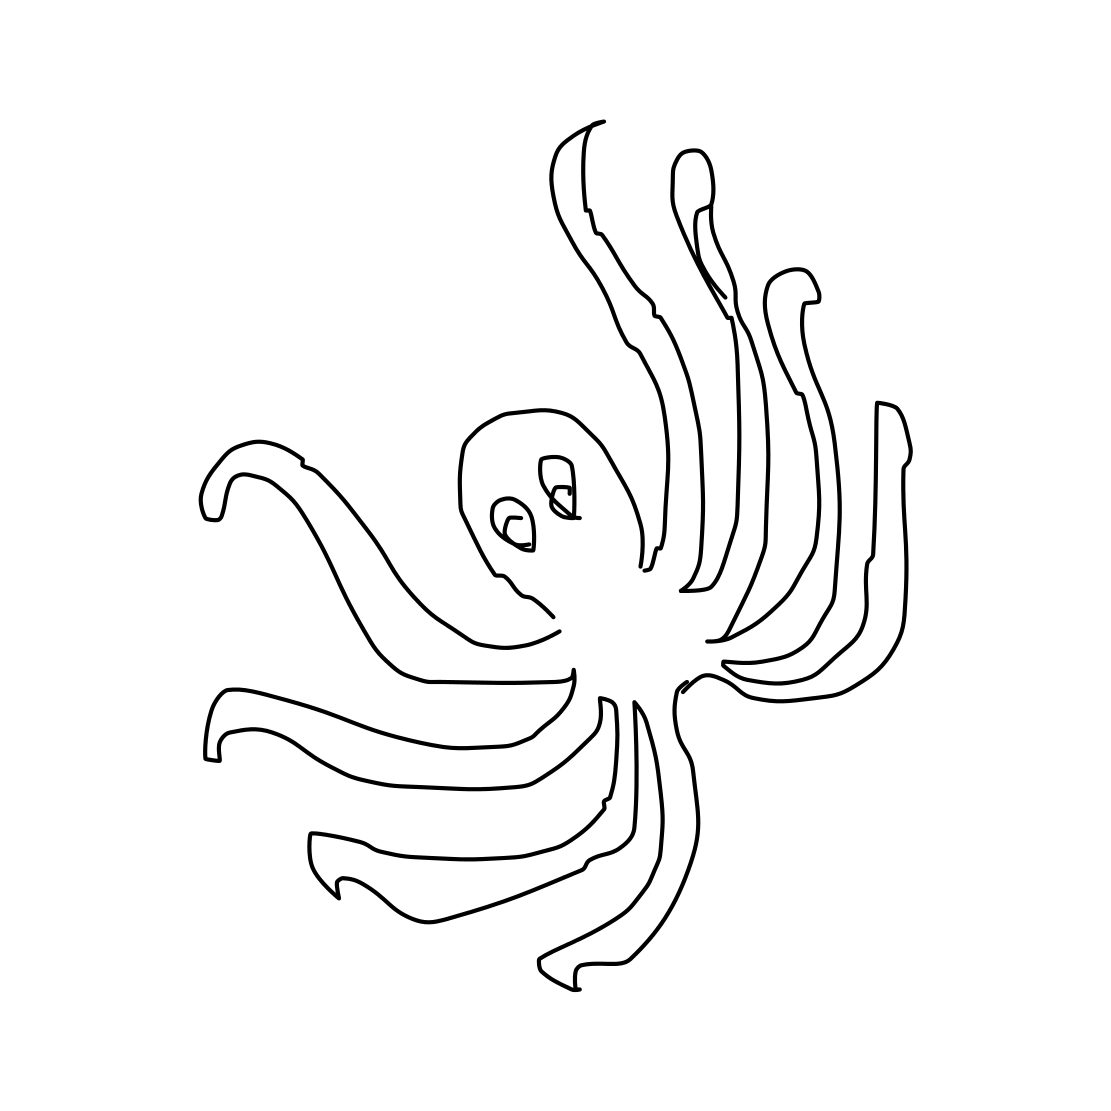Is there a sketchy octopus in the picture? Yes, there is indeed a sketch of an octopus in the picture. The octopus appears with a simple but expressive outline, featuring notable details such as its large, curious eyes and dynamically spread tentacles. 